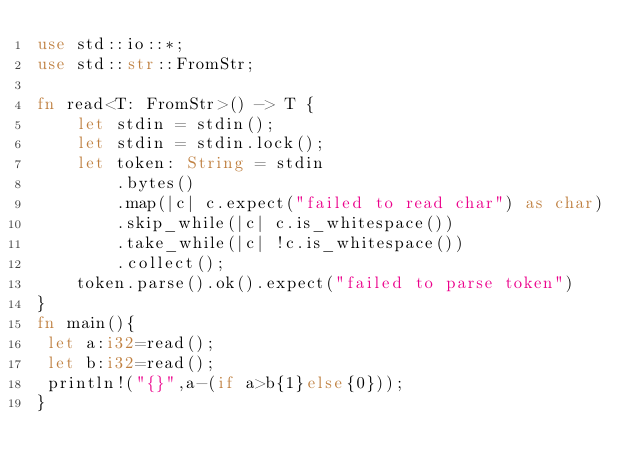<code> <loc_0><loc_0><loc_500><loc_500><_Rust_>use std::io::*;
use std::str::FromStr;

fn read<T: FromStr>() -> T {
    let stdin = stdin();
    let stdin = stdin.lock();
    let token: String = stdin
        .bytes()
        .map(|c| c.expect("failed to read char") as char) 
        .skip_while(|c| c.is_whitespace())
        .take_while(|c| !c.is_whitespace())
        .collect();
    token.parse().ok().expect("failed to parse token")
}
fn main(){
 let a:i32=read();
 let b:i32=read();
 println!("{}",a-(if a>b{1}else{0}));
}</code> 